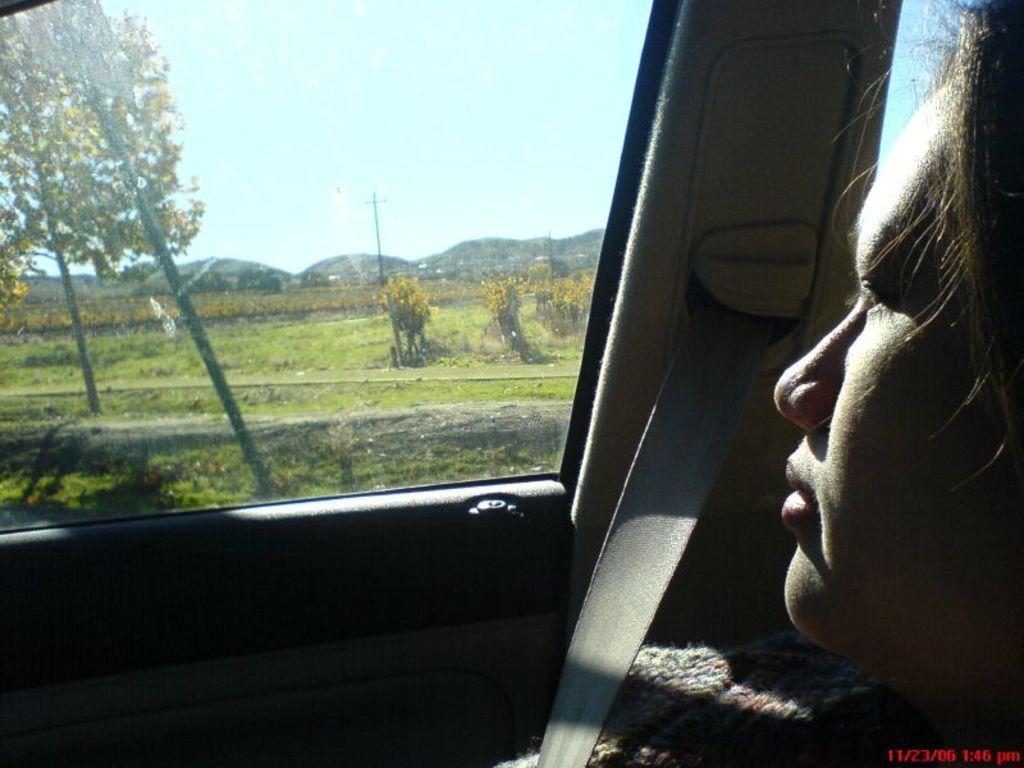How would you summarize this image in a sentence or two? In this image I can see the person sitting in the vehicle. In the background I can see few trees in green color, few electric poles, mountains and the sky is in blue and white color. 